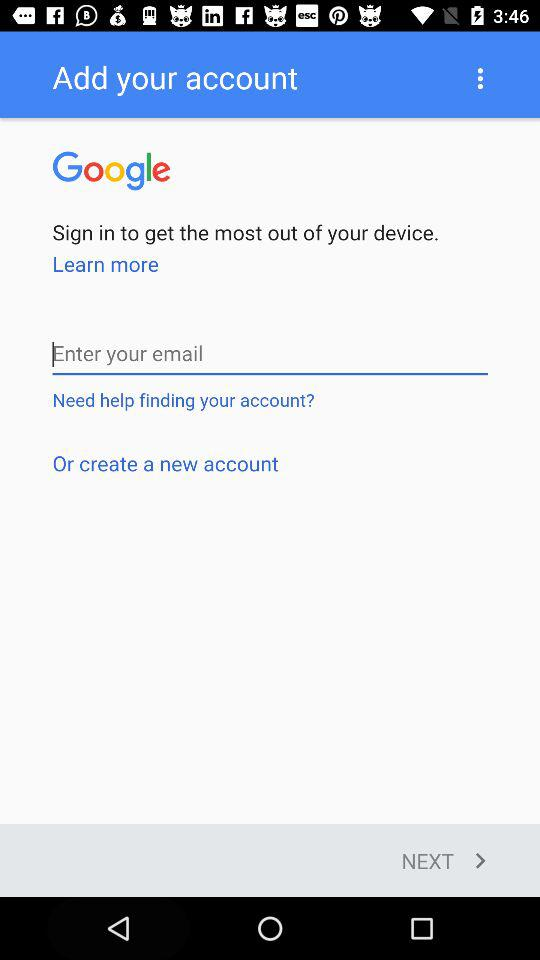Is the date of birth required to create a new account?
When the provided information is insufficient, respond with <no answer>. <no answer> 